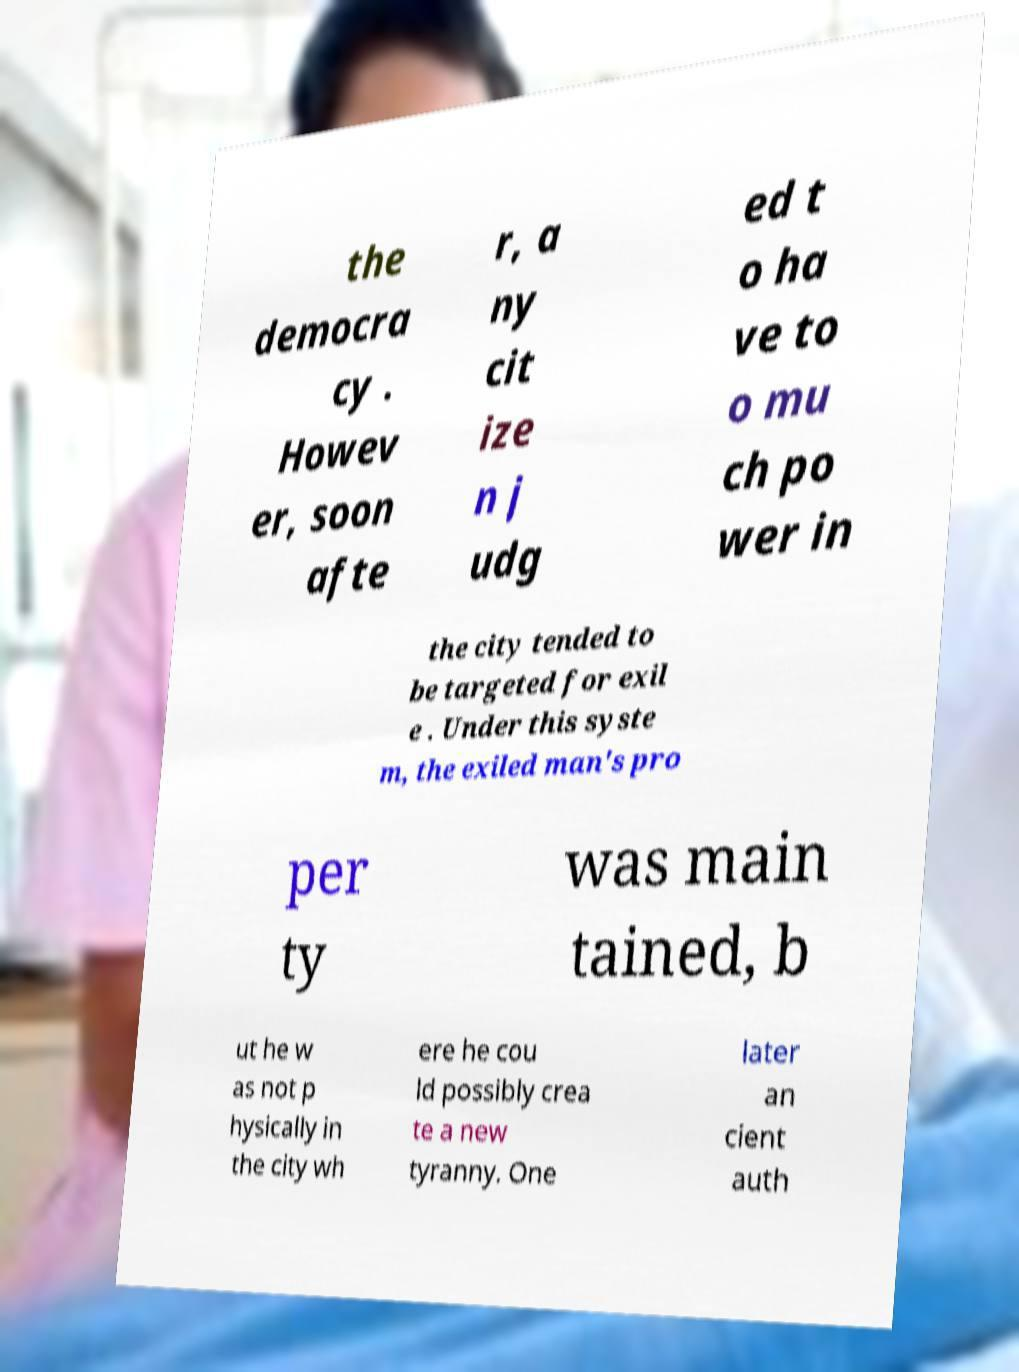Could you assist in decoding the text presented in this image and type it out clearly? the democra cy . Howev er, soon afte r, a ny cit ize n j udg ed t o ha ve to o mu ch po wer in the city tended to be targeted for exil e . Under this syste m, the exiled man's pro per ty was main tained, b ut he w as not p hysically in the city wh ere he cou ld possibly crea te a new tyranny. One later an cient auth 